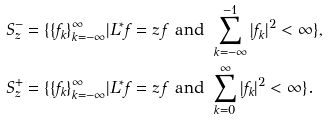<formula> <loc_0><loc_0><loc_500><loc_500>S ^ { - } _ { z } & = \{ \{ f _ { k } \} _ { k = - \infty } ^ { \infty } | L ^ { \ast } f = z \, f \text {\ and\ } \sum _ { k = - \infty } ^ { - 1 } | f _ { k } | ^ { 2 } < \infty \} , \\ S ^ { + } _ { z } & = \{ \{ f _ { k } \} _ { k = - \infty } ^ { \infty } | L ^ { \ast } f = z \, f \text {\ and\ } \sum _ { k = 0 } ^ { \infty } | f _ { k } | ^ { 2 } < \infty \} .</formula> 